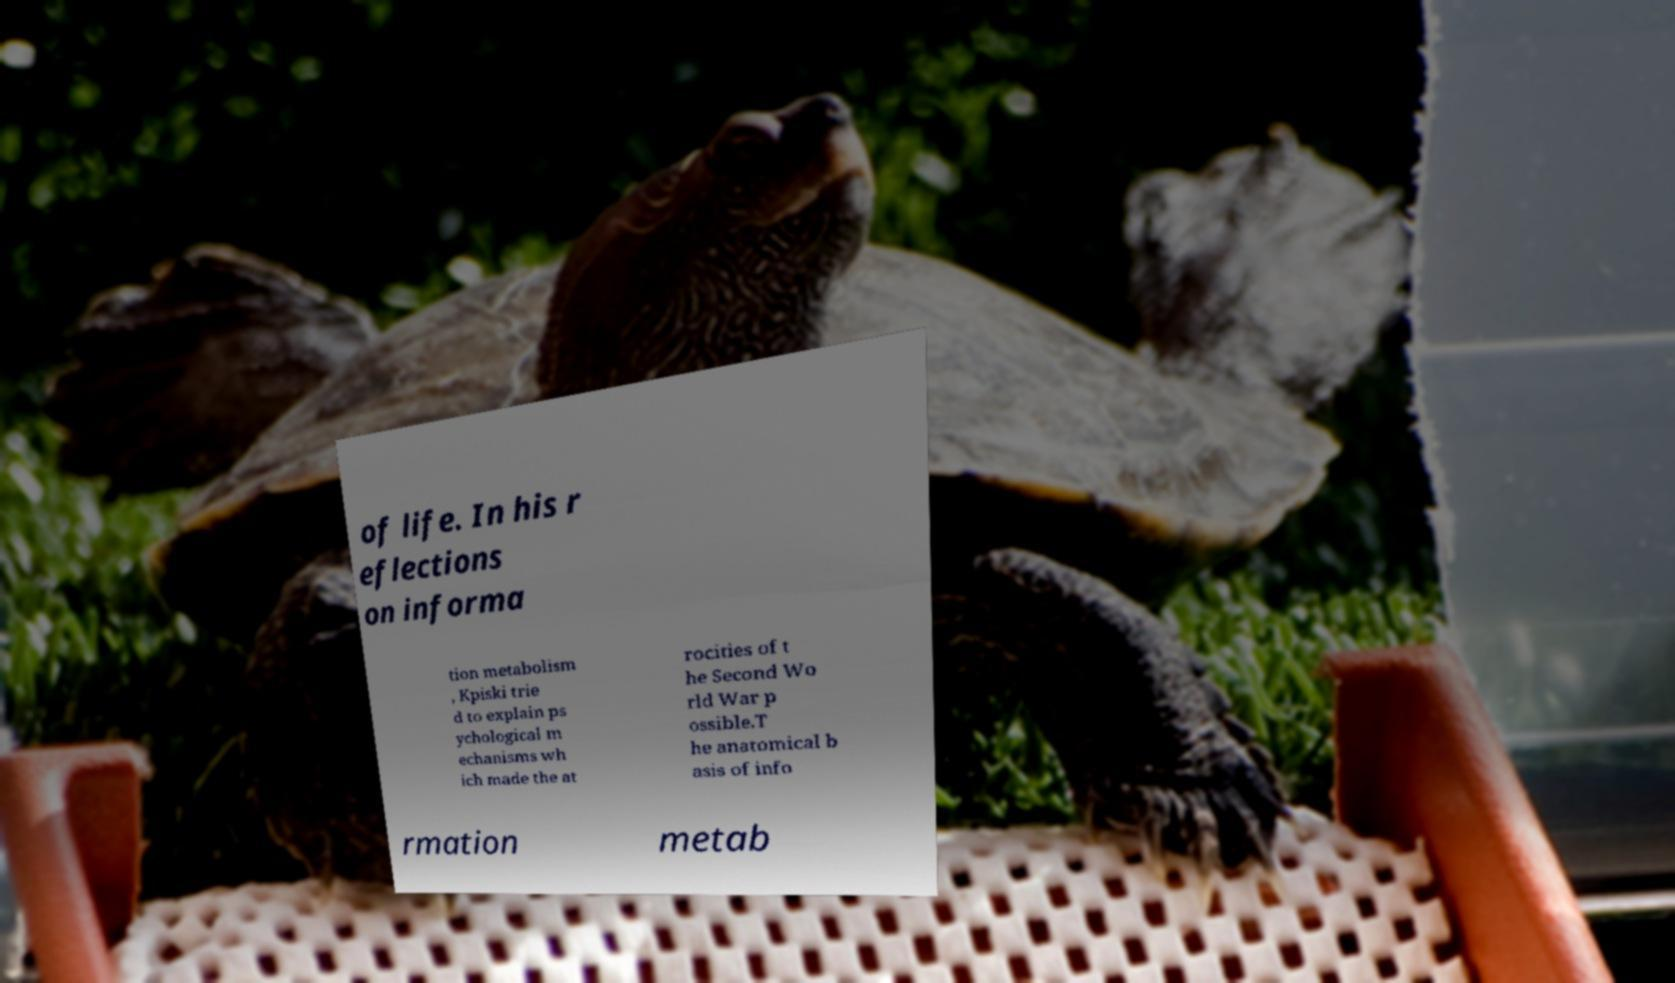What messages or text are displayed in this image? I need them in a readable, typed format. of life. In his r eflections on informa tion metabolism , Kpiski trie d to explain ps ychological m echanisms wh ich made the at rocities of t he Second Wo rld War p ossible.T he anatomical b asis of info rmation metab 